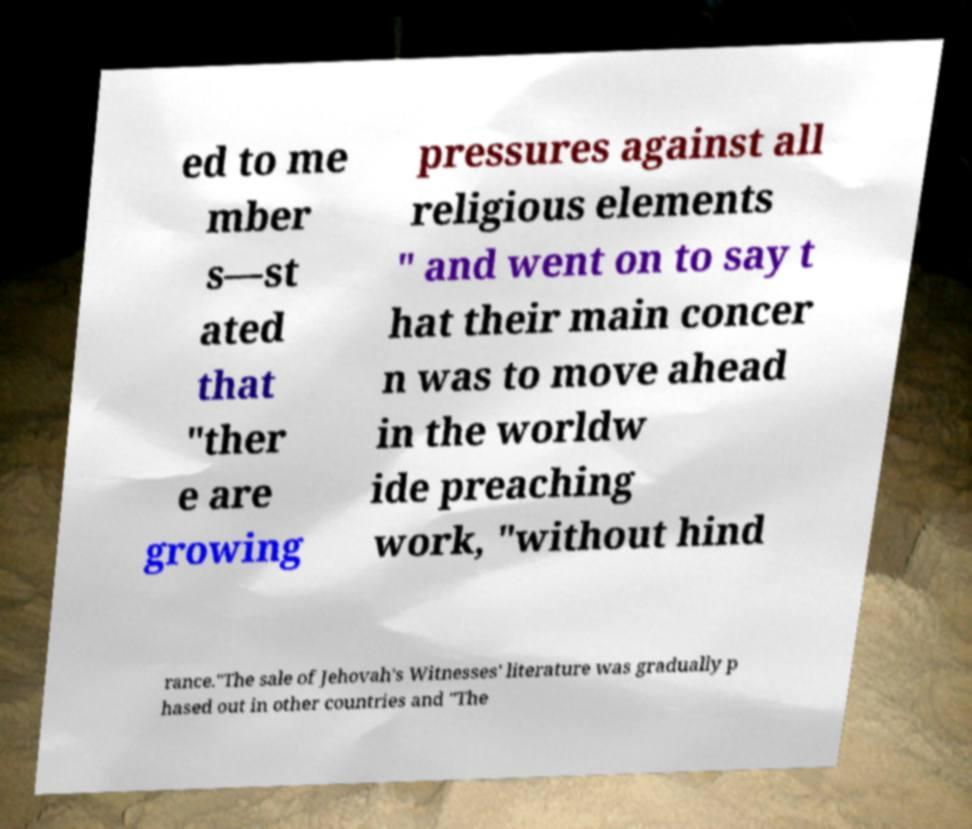What messages or text are displayed in this image? I need them in a readable, typed format. ed to me mber s—st ated that "ther e are growing pressures against all religious elements " and went on to say t hat their main concer n was to move ahead in the worldw ide preaching work, "without hind rance."The sale of Jehovah's Witnesses' literature was gradually p hased out in other countries and "The 